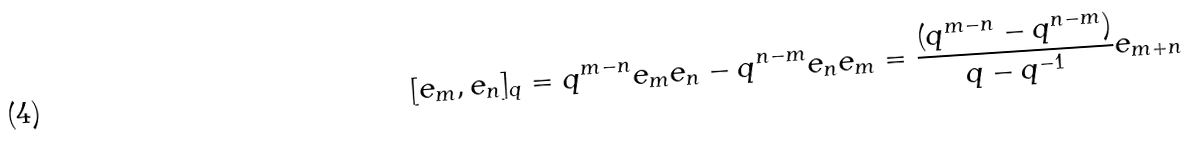Convert formula to latex. <formula><loc_0><loc_0><loc_500><loc_500>[ e _ { m } , e _ { n } ] _ { q } = q ^ { m - n } e _ { m } e _ { n } - q ^ { n - m } e _ { n } e _ { m } = \frac { ( q ^ { m - n } - q ^ { n - m } ) } { q - q ^ { - 1 } } e _ { m + n }</formula> 